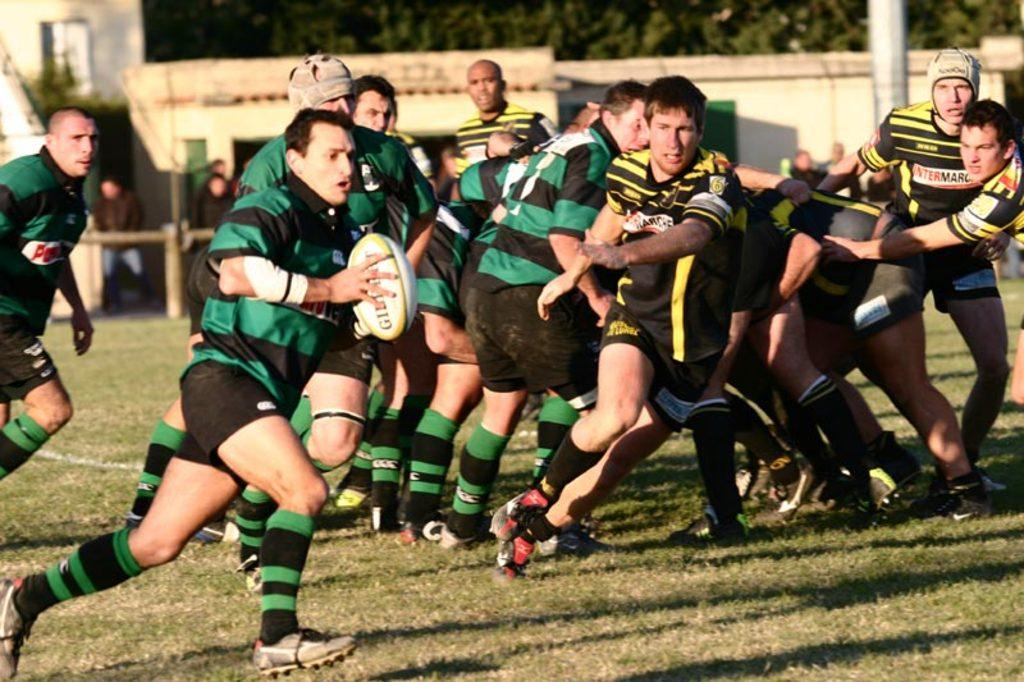What are the people in the image doing? There is a group of people playing in the image. What colors are the t-shirts of some of the people? Some of the people are wearing green t-shirts, while others are wearing black and yellow t-shirts. What type of surface can be seen in the image? There is grass visible in the image. How many ministers are present in the image? There is no mention of a minister or any religious figures in the image. Are there any sisters in the group of people playing? The image does not specify the relationships between the people, so it cannot be determined if there are any sisters present. 